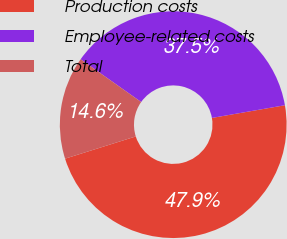Convert chart to OTSL. <chart><loc_0><loc_0><loc_500><loc_500><pie_chart><fcel>Production costs<fcel>Employee-related costs<fcel>Total<nl><fcel>47.89%<fcel>37.47%<fcel>14.63%<nl></chart> 